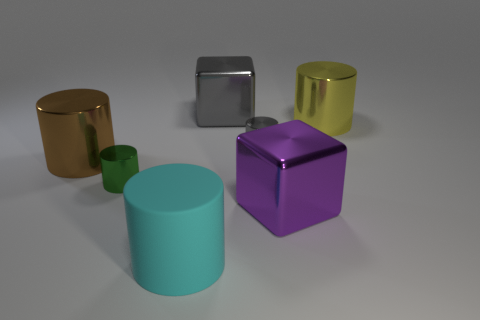Subtract all yellow cylinders. How many cylinders are left? 4 Subtract all tiny cylinders. How many cylinders are left? 3 Subtract all green cylinders. Subtract all brown balls. How many cylinders are left? 4 Add 1 cyan cylinders. How many objects exist? 8 Subtract all cubes. How many objects are left? 5 Subtract all tiny metal cylinders. Subtract all brown cylinders. How many objects are left? 4 Add 6 purple cubes. How many purple cubes are left? 7 Add 1 cubes. How many cubes exist? 3 Subtract 1 green cylinders. How many objects are left? 6 